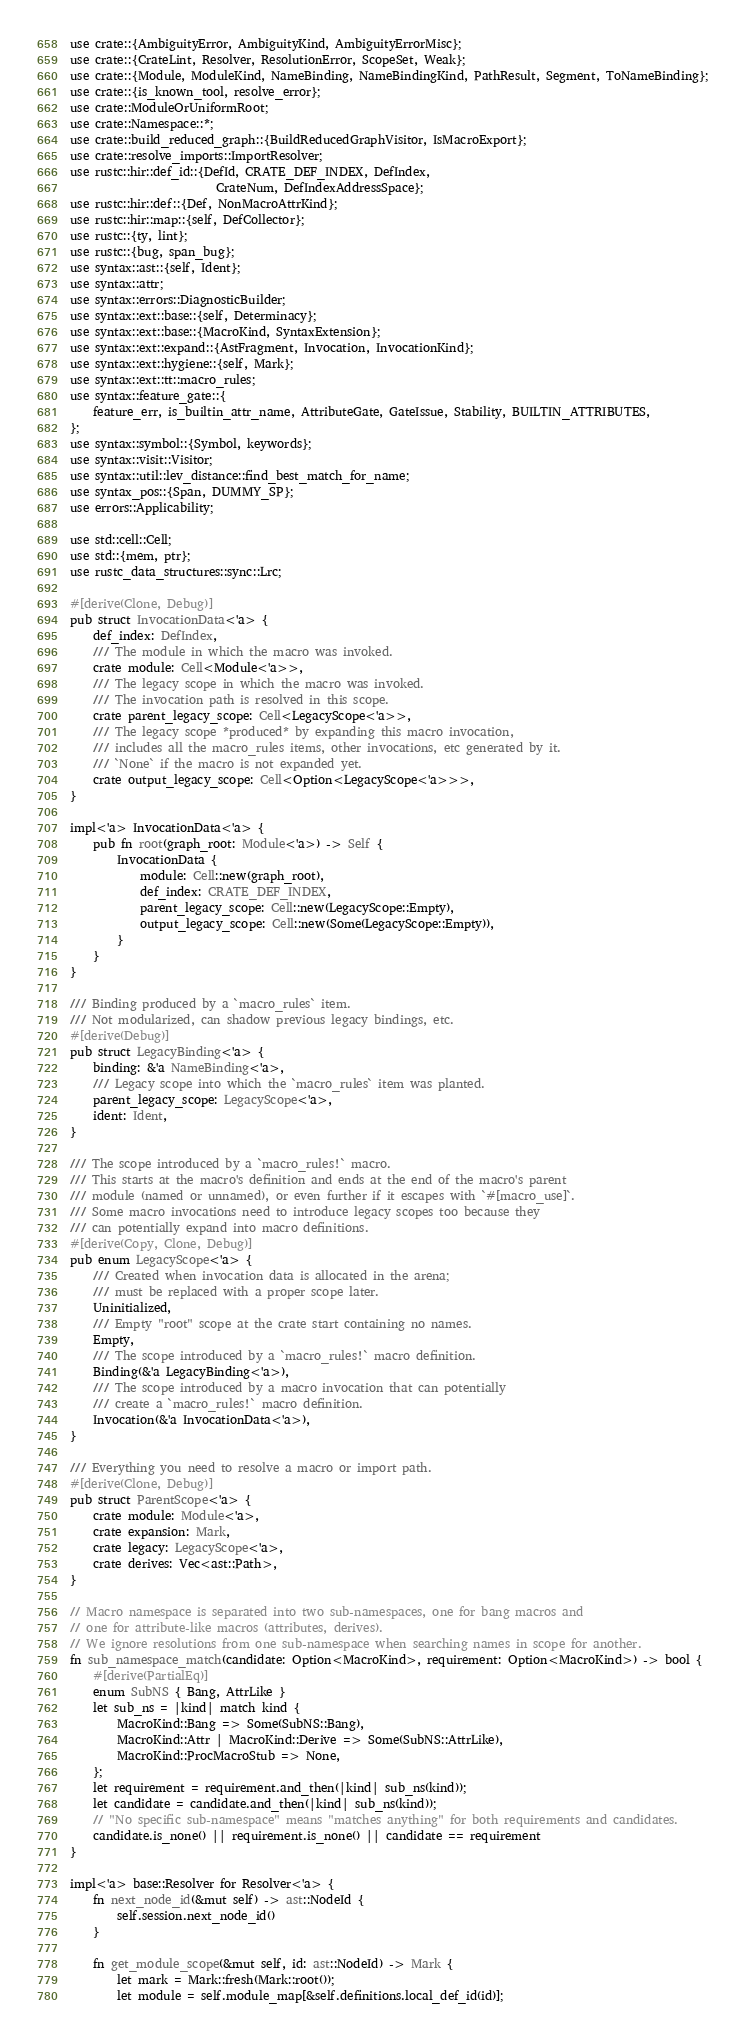<code> <loc_0><loc_0><loc_500><loc_500><_Rust_>use crate::{AmbiguityError, AmbiguityKind, AmbiguityErrorMisc};
use crate::{CrateLint, Resolver, ResolutionError, ScopeSet, Weak};
use crate::{Module, ModuleKind, NameBinding, NameBindingKind, PathResult, Segment, ToNameBinding};
use crate::{is_known_tool, resolve_error};
use crate::ModuleOrUniformRoot;
use crate::Namespace::*;
use crate::build_reduced_graph::{BuildReducedGraphVisitor, IsMacroExport};
use crate::resolve_imports::ImportResolver;
use rustc::hir::def_id::{DefId, CRATE_DEF_INDEX, DefIndex,
                         CrateNum, DefIndexAddressSpace};
use rustc::hir::def::{Def, NonMacroAttrKind};
use rustc::hir::map::{self, DefCollector};
use rustc::{ty, lint};
use rustc::{bug, span_bug};
use syntax::ast::{self, Ident};
use syntax::attr;
use syntax::errors::DiagnosticBuilder;
use syntax::ext::base::{self, Determinacy};
use syntax::ext::base::{MacroKind, SyntaxExtension};
use syntax::ext::expand::{AstFragment, Invocation, InvocationKind};
use syntax::ext::hygiene::{self, Mark};
use syntax::ext::tt::macro_rules;
use syntax::feature_gate::{
    feature_err, is_builtin_attr_name, AttributeGate, GateIssue, Stability, BUILTIN_ATTRIBUTES,
};
use syntax::symbol::{Symbol, keywords};
use syntax::visit::Visitor;
use syntax::util::lev_distance::find_best_match_for_name;
use syntax_pos::{Span, DUMMY_SP};
use errors::Applicability;

use std::cell::Cell;
use std::{mem, ptr};
use rustc_data_structures::sync::Lrc;

#[derive(Clone, Debug)]
pub struct InvocationData<'a> {
    def_index: DefIndex,
    /// The module in which the macro was invoked.
    crate module: Cell<Module<'a>>,
    /// The legacy scope in which the macro was invoked.
    /// The invocation path is resolved in this scope.
    crate parent_legacy_scope: Cell<LegacyScope<'a>>,
    /// The legacy scope *produced* by expanding this macro invocation,
    /// includes all the macro_rules items, other invocations, etc generated by it.
    /// `None` if the macro is not expanded yet.
    crate output_legacy_scope: Cell<Option<LegacyScope<'a>>>,
}

impl<'a> InvocationData<'a> {
    pub fn root(graph_root: Module<'a>) -> Self {
        InvocationData {
            module: Cell::new(graph_root),
            def_index: CRATE_DEF_INDEX,
            parent_legacy_scope: Cell::new(LegacyScope::Empty),
            output_legacy_scope: Cell::new(Some(LegacyScope::Empty)),
        }
    }
}

/// Binding produced by a `macro_rules` item.
/// Not modularized, can shadow previous legacy bindings, etc.
#[derive(Debug)]
pub struct LegacyBinding<'a> {
    binding: &'a NameBinding<'a>,
    /// Legacy scope into which the `macro_rules` item was planted.
    parent_legacy_scope: LegacyScope<'a>,
    ident: Ident,
}

/// The scope introduced by a `macro_rules!` macro.
/// This starts at the macro's definition and ends at the end of the macro's parent
/// module (named or unnamed), or even further if it escapes with `#[macro_use]`.
/// Some macro invocations need to introduce legacy scopes too because they
/// can potentially expand into macro definitions.
#[derive(Copy, Clone, Debug)]
pub enum LegacyScope<'a> {
    /// Created when invocation data is allocated in the arena;
    /// must be replaced with a proper scope later.
    Uninitialized,
    /// Empty "root" scope at the crate start containing no names.
    Empty,
    /// The scope introduced by a `macro_rules!` macro definition.
    Binding(&'a LegacyBinding<'a>),
    /// The scope introduced by a macro invocation that can potentially
    /// create a `macro_rules!` macro definition.
    Invocation(&'a InvocationData<'a>),
}

/// Everything you need to resolve a macro or import path.
#[derive(Clone, Debug)]
pub struct ParentScope<'a> {
    crate module: Module<'a>,
    crate expansion: Mark,
    crate legacy: LegacyScope<'a>,
    crate derives: Vec<ast::Path>,
}

// Macro namespace is separated into two sub-namespaces, one for bang macros and
// one for attribute-like macros (attributes, derives).
// We ignore resolutions from one sub-namespace when searching names in scope for another.
fn sub_namespace_match(candidate: Option<MacroKind>, requirement: Option<MacroKind>) -> bool {
    #[derive(PartialEq)]
    enum SubNS { Bang, AttrLike }
    let sub_ns = |kind| match kind {
        MacroKind::Bang => Some(SubNS::Bang),
        MacroKind::Attr | MacroKind::Derive => Some(SubNS::AttrLike),
        MacroKind::ProcMacroStub => None,
    };
    let requirement = requirement.and_then(|kind| sub_ns(kind));
    let candidate = candidate.and_then(|kind| sub_ns(kind));
    // "No specific sub-namespace" means "matches anything" for both requirements and candidates.
    candidate.is_none() || requirement.is_none() || candidate == requirement
}

impl<'a> base::Resolver for Resolver<'a> {
    fn next_node_id(&mut self) -> ast::NodeId {
        self.session.next_node_id()
    }

    fn get_module_scope(&mut self, id: ast::NodeId) -> Mark {
        let mark = Mark::fresh(Mark::root());
        let module = self.module_map[&self.definitions.local_def_id(id)];</code> 